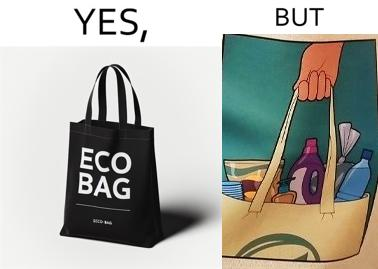What is the satirical meaning behind this image? The image is ironical because in the left image it is written eco bag but in the right image we are keeping items of plastic which is not eco-friendly. 